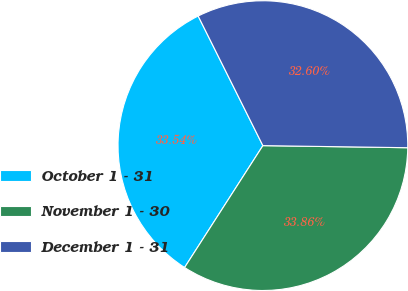Convert chart to OTSL. <chart><loc_0><loc_0><loc_500><loc_500><pie_chart><fcel>October 1 - 31<fcel>November 1 - 30<fcel>December 1 - 31<nl><fcel>33.54%<fcel>33.86%<fcel>32.6%<nl></chart> 